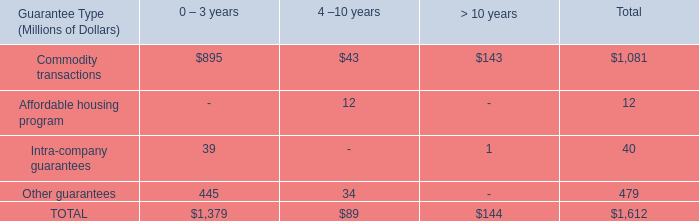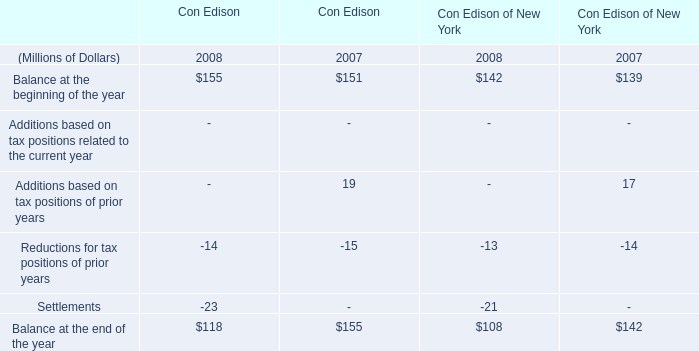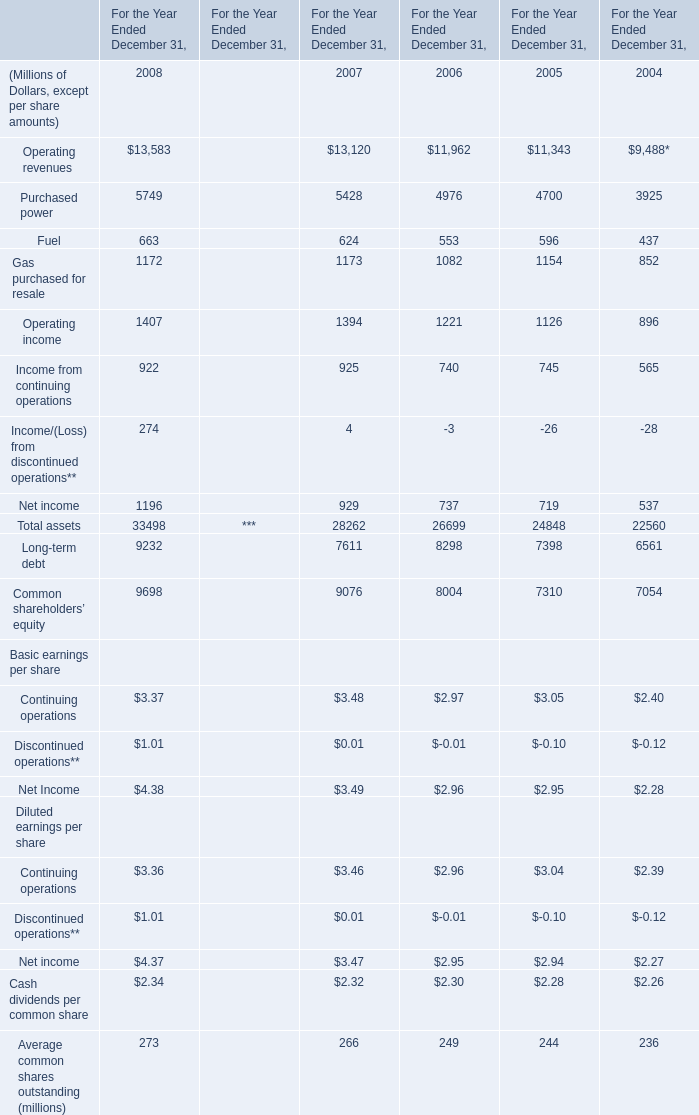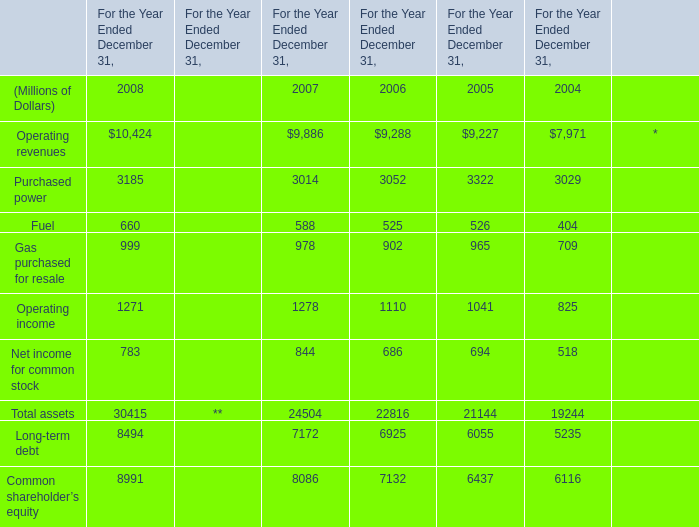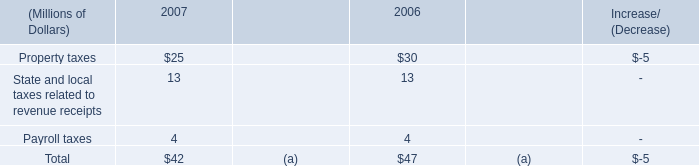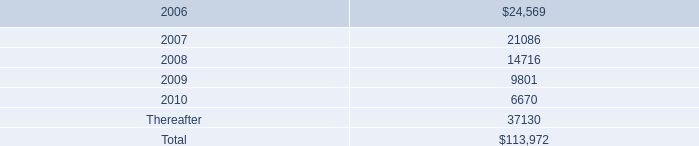What is the growing rate of Operating revenues in the year with the most Operating income? 
Computations: ((9886 - 9288) / 9288)
Answer: 0.06438. 